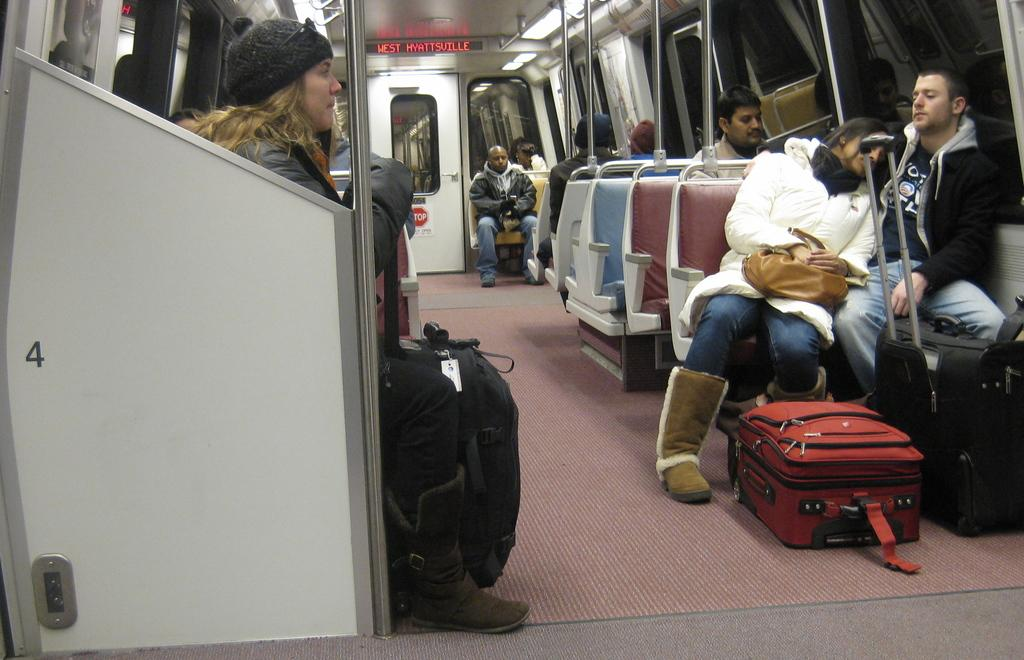Who or what is present in the image? There are people in the image. What are the people doing in the image? The people are sitting on chairs. What else can be seen on the floor in the image? There are suitcases on the floor. What type of argument can be seen taking place between the people in the image? There is no argument present in the image; the people are simply sitting on chairs. 